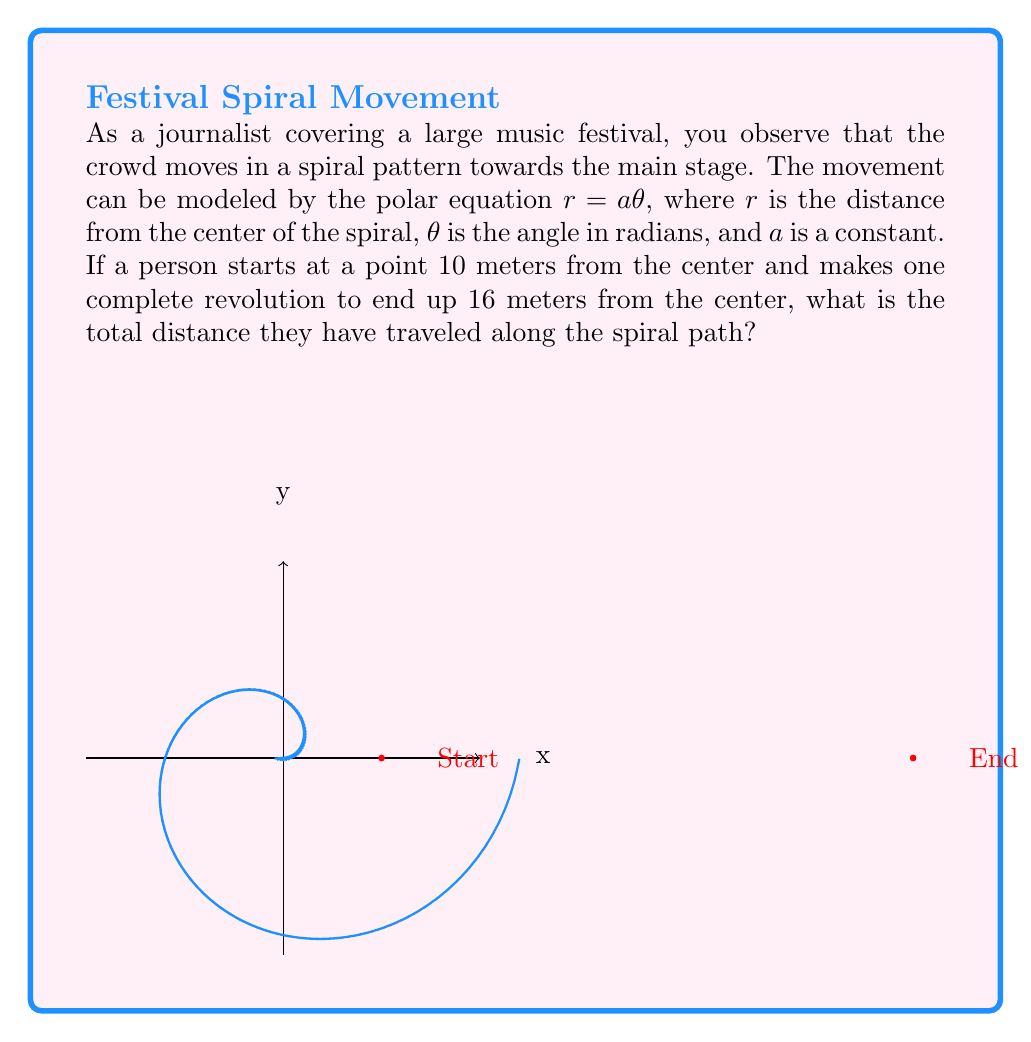Help me with this question. Let's approach this step-by-step:

1) First, we need to find the value of $a$ in the equation $r = a\theta$. We know two points on the spiral:
   - Start: $r_1 = 10$, $\theta_1 = 0$
   - End: $r_2 = 16$, $\theta_2 = 2\pi$ (one complete revolution)

2) Using the end point: $16 = a(2\pi)$
   Solving for $a$: $a = \frac{16}{2\pi} = \frac{8}{\pi}$

3) The spiral equation is now $r = \frac{8}{\pi}\theta$

4) To find the length of the spiral path, we use the arc length formula for polar curves:
   $$L = \int_0^{2\pi} \sqrt{r^2 + \left(\frac{dr}{d\theta}\right)^2} d\theta$$

5) We need to calculate $\frac{dr}{d\theta}$:
   $\frac{dr}{d\theta} = \frac{8}{\pi}$

6) Substituting into the arc length formula:
   $$L = \int_0^{2\pi} \sqrt{\left(\frac{8}{\pi}\theta\right)^2 + \left(\frac{8}{\pi}\right)^2} d\theta$$

7) Simplifying inside the square root:
   $$L = \int_0^{2\pi} \frac{8}{\pi}\sqrt{\theta^2 + 1} d\theta$$

8) This integral doesn't have an elementary antiderivative, so we need to use numerical integration. Using a calculator or computer algebra system, we get:

   $$L \approx 20.66 \text{ meters}$$
Answer: $20.66$ meters 